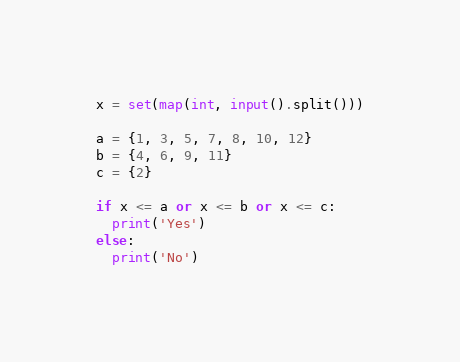Convert code to text. <code><loc_0><loc_0><loc_500><loc_500><_Python_>x = set(map(int, input().split()))

a = {1, 3, 5, 7, 8, 10, 12}
b = {4, 6, 9, 11}
c = {2}

if x <= a or x <= b or x <= c:
  print('Yes')
else:
  print('No')</code> 